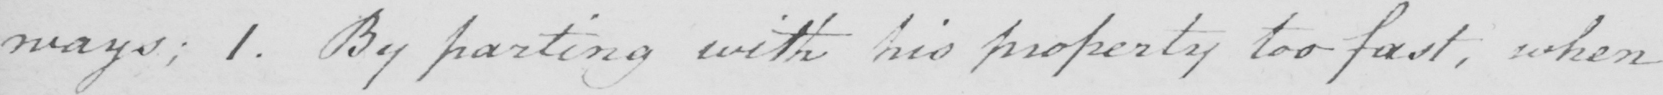Can you read and transcribe this handwriting? ways ; 1 . By parting with his property too fast , when 